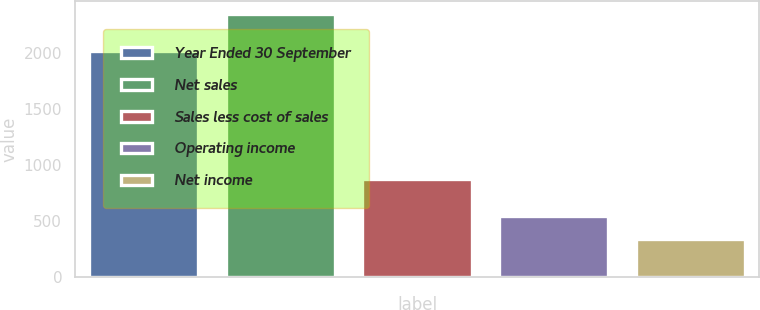Convert chart. <chart><loc_0><loc_0><loc_500><loc_500><bar_chart><fcel>Year Ended 30 September<fcel>Net sales<fcel>Sales less cost of sales<fcel>Operating income<fcel>Net income<nl><fcel>2017<fcel>2343.3<fcel>878.6<fcel>543.48<fcel>343.5<nl></chart> 